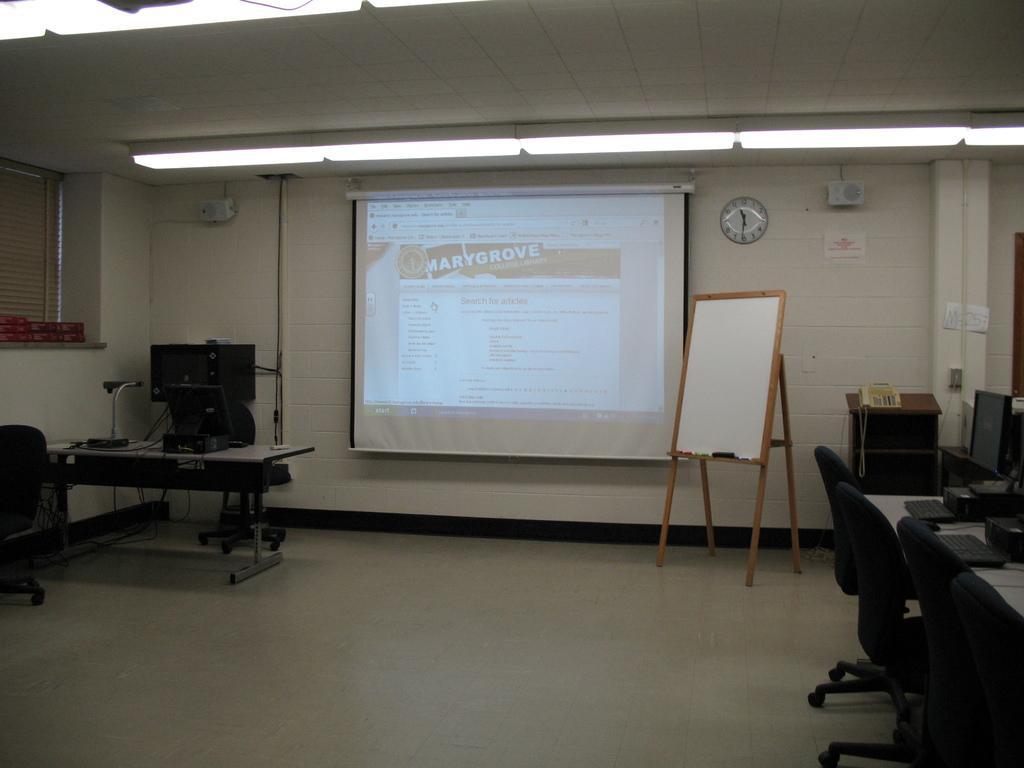In one or two sentences, can you explain what this image depicts? In this image I can see few chairs, in front I can see a white color board. Background I can see a projector screen and a clock attached to the wall and the wall is in white color. 